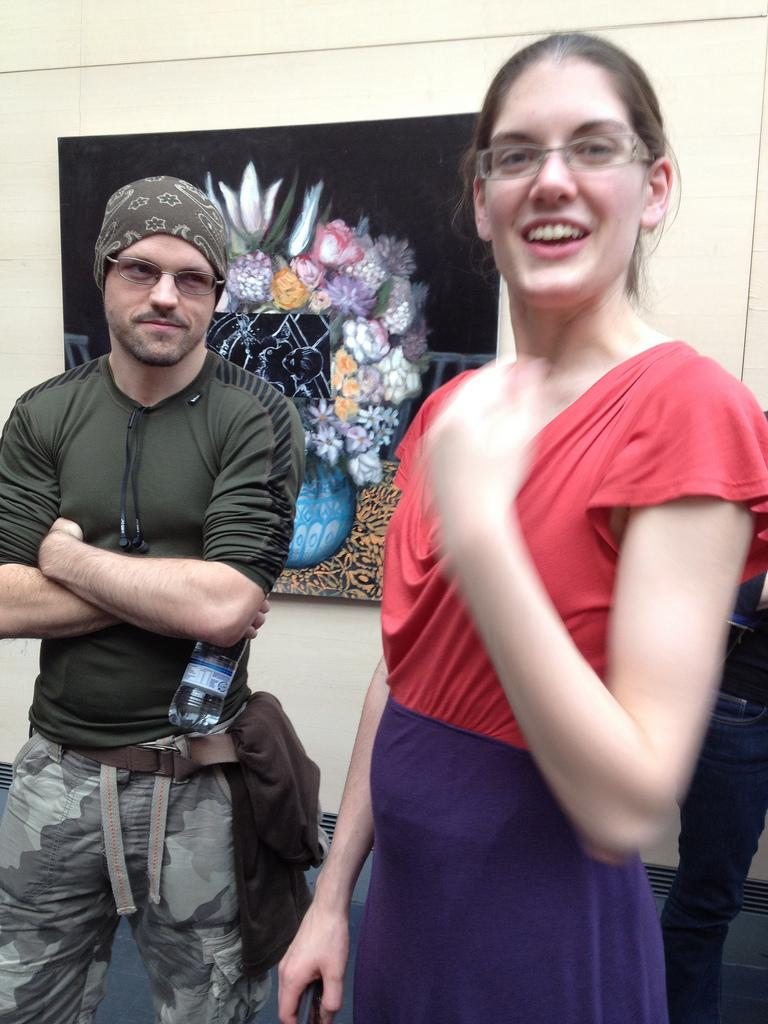Who are the two people in the image? There is a man and a lady standing in the center of the image. What are they doing in the image? The provided facts do not specify what the man and lady are doing, but they are standing in the center of the image. What can be seen on the wall in the background of the image? There is a wall frame placed on the wall in the background of the image. Where is the toothbrush placed in the image? There is no toothbrush present in the image. Can you see any ducks in the image? There are no ducks present in the image. 